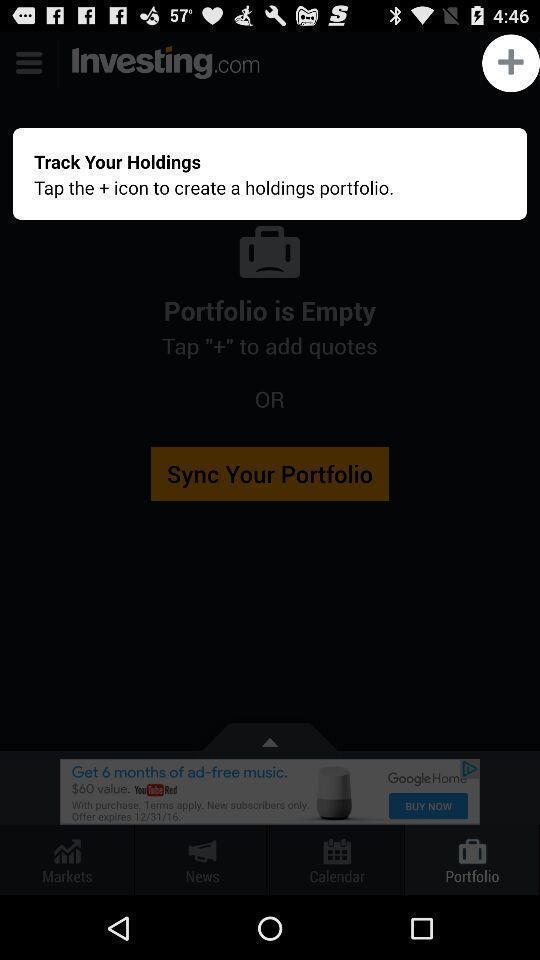Tell me about the visual elements in this screen capture. Pop-up shows track holdings portfolio. 